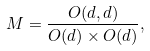Convert formula to latex. <formula><loc_0><loc_0><loc_500><loc_500>M = \frac { O ( d , d ) } { O ( d ) \times O ( d ) } ,</formula> 